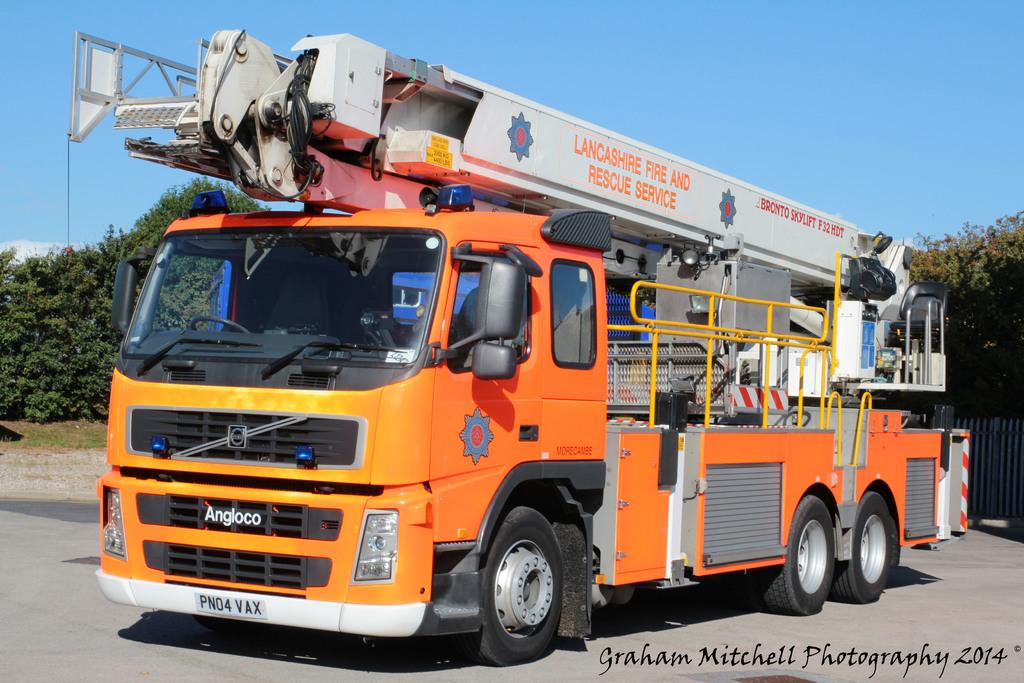What is the main subject of the image? The main subject of the image is a truck. What can be seen on the truck? The truck has logos and text on it. What is visible in the background of the image? There are trees in the background of the image. What type of barrier is present in the image? There is fencing in the image. What is visible at the top of the image? The sky is visible in the image. What can be found at the bottom of the image? There is text at the bottom of the image. What type of plantation can be seen in the image? There is no plantation present in the image; it features a truck with logos and text, trees in the background, fencing, and text at the bottom. What is the rate of the truck's speed in the image? The image does not provide any information about the truck's speed, so it cannot be determined. 